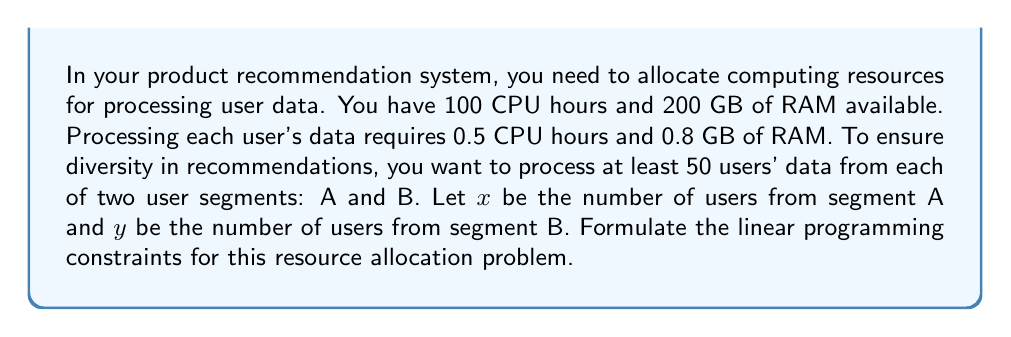Can you solve this math problem? Let's break down the problem and formulate the constraints step-by-step:

1. Resource constraints:
   a) CPU constraint:
      Total CPU hours used ≤ Available CPU hours
      $0.5x + 0.5y \leq 100$

   b) RAM constraint:
      Total RAM used ≤ Available RAM
      $0.8x + 0.8y \leq 200$

2. Minimum user constraints:
   a) Segment A: $x \geq 50$
   b) Segment B: $y \geq 50$

3. Non-negativity constraints:
   $x \geq 0$ and $y \geq 0$

Combining all these constraints, we get the following system of inequalities:

$$
\begin{align*}
0.5x + 0.5y &\leq 100 \\
0.8x + 0.8y &\leq 200 \\
x &\geq 50 \\
y &\geq 50 \\
x, y &\geq 0
\end{align*}
$$

This system of inequalities represents the constraints for the linear programming problem of resource allocation in the product recommendation system.
Answer: $$
\begin{align*}
0.5x + 0.5y &\leq 100 \\
0.8x + 0.8y &\leq 200 \\
x &\geq 50 \\
y &\geq 50 \\
x, y &\geq 0
\end{align*}
$$ 